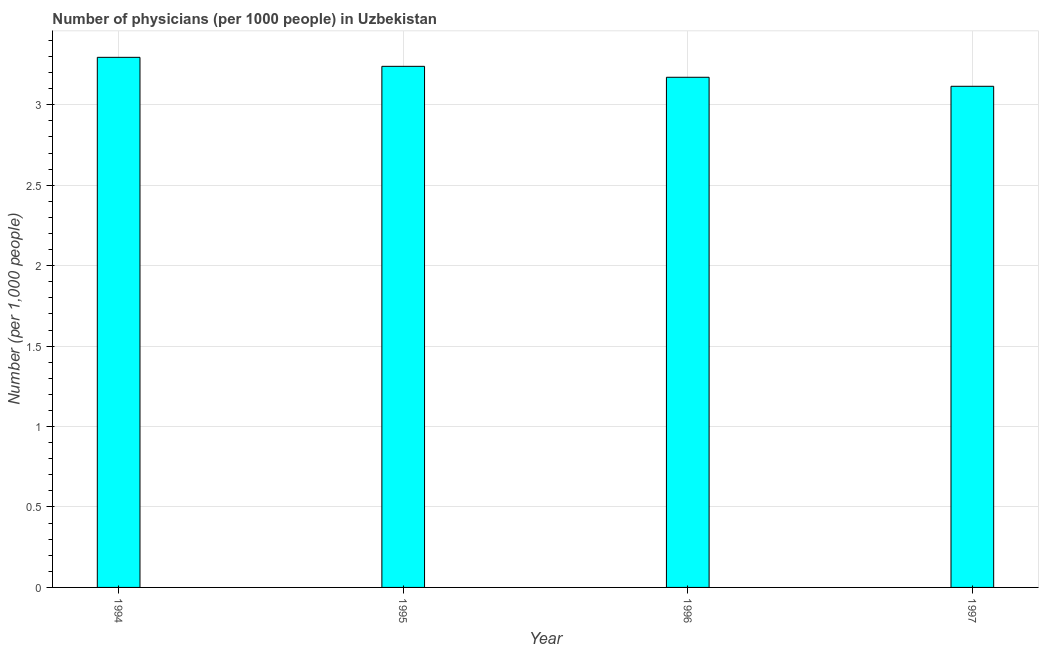Does the graph contain grids?
Offer a terse response. Yes. What is the title of the graph?
Ensure brevity in your answer.  Number of physicians (per 1000 people) in Uzbekistan. What is the label or title of the Y-axis?
Keep it short and to the point. Number (per 1,0 people). What is the number of physicians in 1996?
Provide a short and direct response. 3.17. Across all years, what is the maximum number of physicians?
Make the answer very short. 3.3. Across all years, what is the minimum number of physicians?
Offer a very short reply. 3.12. In which year was the number of physicians maximum?
Provide a succinct answer. 1994. In which year was the number of physicians minimum?
Make the answer very short. 1997. What is the sum of the number of physicians?
Provide a succinct answer. 12.82. What is the difference between the number of physicians in 1994 and 1997?
Keep it short and to the point. 0.18. What is the average number of physicians per year?
Ensure brevity in your answer.  3.21. What is the median number of physicians?
Provide a succinct answer. 3.21. In how many years, is the number of physicians greater than 1 ?
Your answer should be very brief. 4. What is the ratio of the number of physicians in 1995 to that in 1997?
Make the answer very short. 1.04. Is the number of physicians in 1994 less than that in 1995?
Give a very brief answer. No. Is the difference between the number of physicians in 1994 and 1997 greater than the difference between any two years?
Offer a terse response. Yes. What is the difference between the highest and the second highest number of physicians?
Provide a short and direct response. 0.06. What is the difference between the highest and the lowest number of physicians?
Your response must be concise. 0.18. How many years are there in the graph?
Keep it short and to the point. 4. What is the difference between two consecutive major ticks on the Y-axis?
Make the answer very short. 0.5. What is the Number (per 1,000 people) of 1994?
Provide a succinct answer. 3.3. What is the Number (per 1,000 people) of 1995?
Offer a very short reply. 3.24. What is the Number (per 1,000 people) in 1996?
Ensure brevity in your answer.  3.17. What is the Number (per 1,000 people) of 1997?
Provide a succinct answer. 3.12. What is the difference between the Number (per 1,000 people) in 1994 and 1995?
Keep it short and to the point. 0.06. What is the difference between the Number (per 1,000 people) in 1994 and 1996?
Provide a short and direct response. 0.12. What is the difference between the Number (per 1,000 people) in 1994 and 1997?
Provide a succinct answer. 0.18. What is the difference between the Number (per 1,000 people) in 1995 and 1996?
Your response must be concise. 0.07. What is the difference between the Number (per 1,000 people) in 1995 and 1997?
Offer a very short reply. 0.12. What is the difference between the Number (per 1,000 people) in 1996 and 1997?
Give a very brief answer. 0.06. What is the ratio of the Number (per 1,000 people) in 1994 to that in 1996?
Your response must be concise. 1.04. What is the ratio of the Number (per 1,000 people) in 1994 to that in 1997?
Make the answer very short. 1.06. What is the ratio of the Number (per 1,000 people) in 1995 to that in 1996?
Your answer should be compact. 1.02. What is the ratio of the Number (per 1,000 people) in 1996 to that in 1997?
Offer a very short reply. 1.02. 